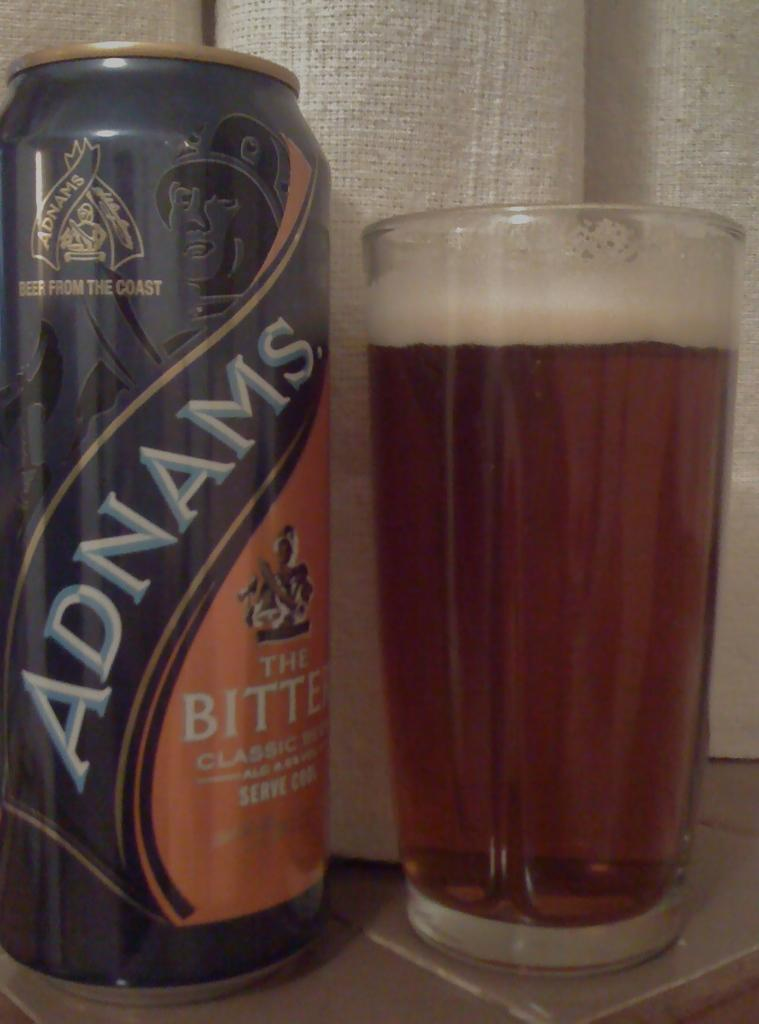<image>
Write a terse but informative summary of the picture. A can of Adnams beer next to a glass full of beer 